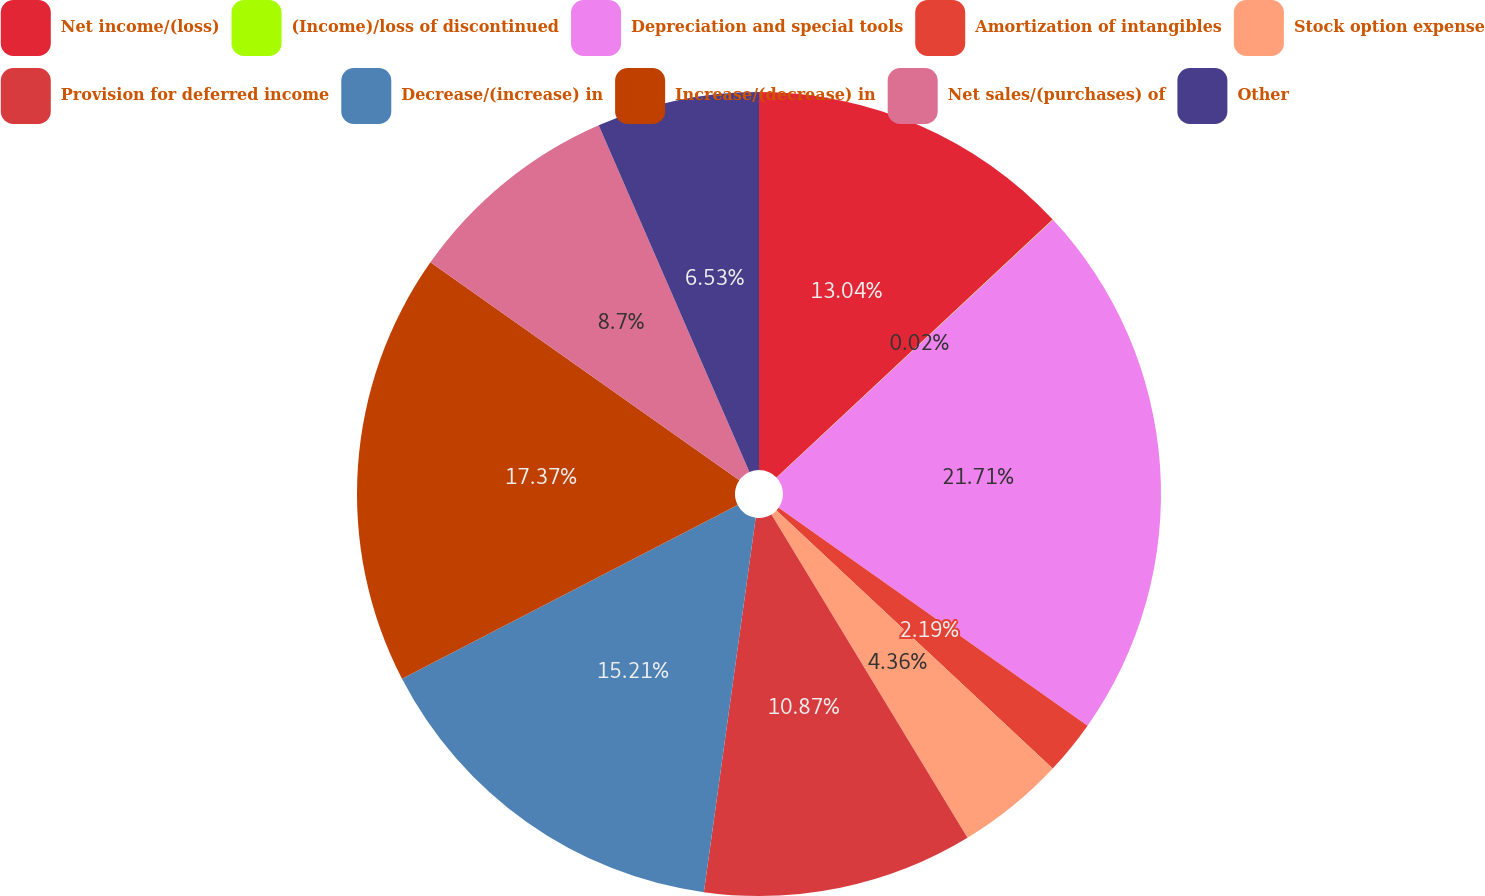<chart> <loc_0><loc_0><loc_500><loc_500><pie_chart><fcel>Net income/(loss)<fcel>(Income)/loss of discontinued<fcel>Depreciation and special tools<fcel>Amortization of intangibles<fcel>Stock option expense<fcel>Provision for deferred income<fcel>Decrease/(increase) in<fcel>Increase/(decrease) in<fcel>Net sales/(purchases) of<fcel>Other<nl><fcel>13.04%<fcel>0.02%<fcel>21.72%<fcel>2.19%<fcel>4.36%<fcel>10.87%<fcel>15.21%<fcel>17.38%<fcel>8.7%<fcel>6.53%<nl></chart> 